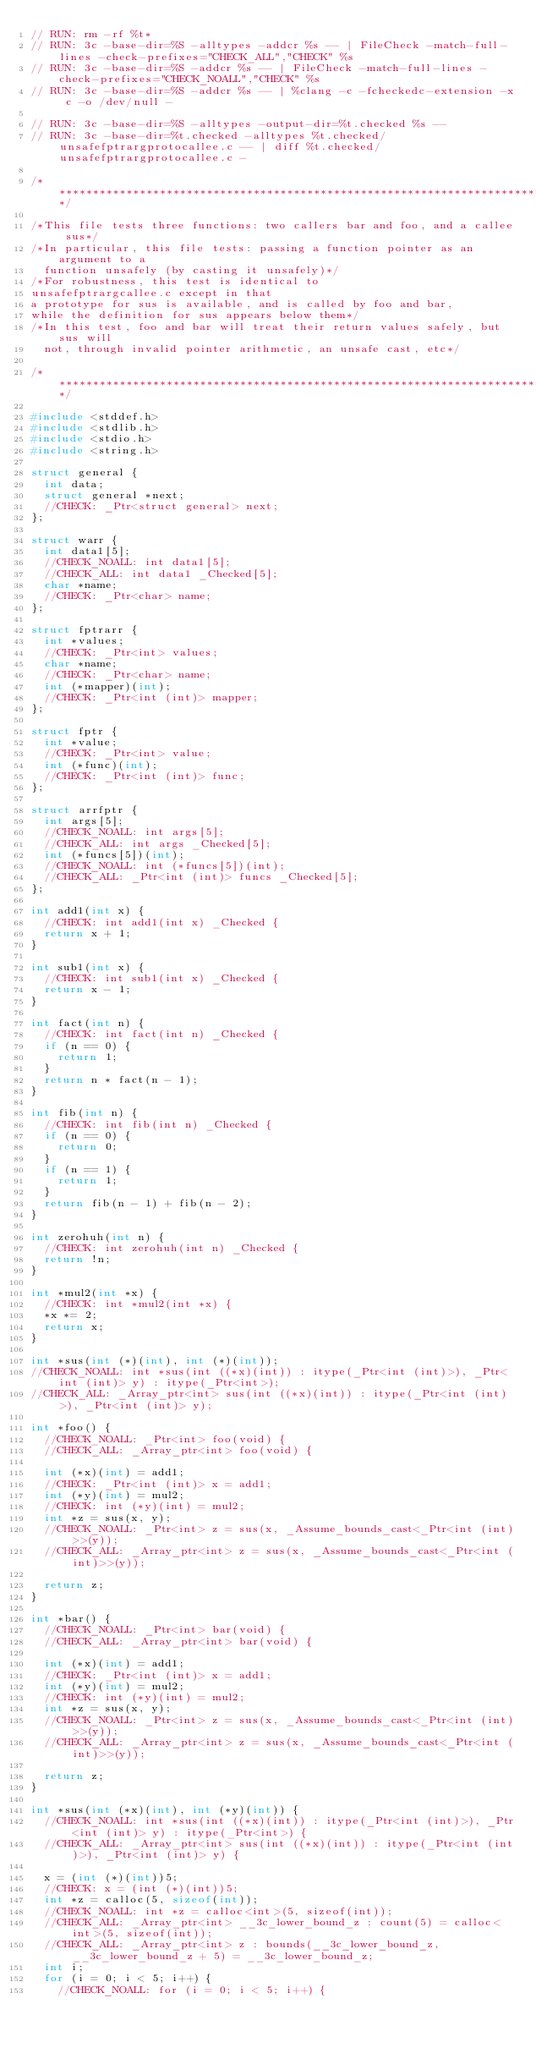<code> <loc_0><loc_0><loc_500><loc_500><_C_>// RUN: rm -rf %t*
// RUN: 3c -base-dir=%S -alltypes -addcr %s -- | FileCheck -match-full-lines -check-prefixes="CHECK_ALL","CHECK" %s
// RUN: 3c -base-dir=%S -addcr %s -- | FileCheck -match-full-lines -check-prefixes="CHECK_NOALL","CHECK" %s
// RUN: 3c -base-dir=%S -addcr %s -- | %clang -c -fcheckedc-extension -x c -o /dev/null -

// RUN: 3c -base-dir=%S -alltypes -output-dir=%t.checked %s --
// RUN: 3c -base-dir=%t.checked -alltypes %t.checked/unsafefptrargprotocallee.c -- | diff %t.checked/unsafefptrargprotocallee.c -

/******************************************************************************/

/*This file tests three functions: two callers bar and foo, and a callee sus*/
/*In particular, this file tests: passing a function pointer as an argument to a
  function unsafely (by casting it unsafely)*/
/*For robustness, this test is identical to
unsafefptrargcallee.c except in that
a prototype for sus is available, and is called by foo and bar,
while the definition for sus appears below them*/
/*In this test, foo and bar will treat their return values safely, but sus will
  not, through invalid pointer arithmetic, an unsafe cast, etc*/

/******************************************************************************/

#include <stddef.h>
#include <stdlib.h>
#include <stdio.h>
#include <string.h>

struct general {
  int data;
  struct general *next;
  //CHECK: _Ptr<struct general> next;
};

struct warr {
  int data1[5];
  //CHECK_NOALL: int data1[5];
  //CHECK_ALL: int data1 _Checked[5];
  char *name;
  //CHECK: _Ptr<char> name;
};

struct fptrarr {
  int *values;
  //CHECK: _Ptr<int> values;
  char *name;
  //CHECK: _Ptr<char> name;
  int (*mapper)(int);
  //CHECK: _Ptr<int (int)> mapper;
};

struct fptr {
  int *value;
  //CHECK: _Ptr<int> value;
  int (*func)(int);
  //CHECK: _Ptr<int (int)> func;
};

struct arrfptr {
  int args[5];
  //CHECK_NOALL: int args[5];
  //CHECK_ALL: int args _Checked[5];
  int (*funcs[5])(int);
  //CHECK_NOALL: int (*funcs[5])(int);
  //CHECK_ALL: _Ptr<int (int)> funcs _Checked[5];
};

int add1(int x) {
  //CHECK: int add1(int x) _Checked {
  return x + 1;
}

int sub1(int x) {
  //CHECK: int sub1(int x) _Checked {
  return x - 1;
}

int fact(int n) {
  //CHECK: int fact(int n) _Checked {
  if (n == 0) {
    return 1;
  }
  return n * fact(n - 1);
}

int fib(int n) {
  //CHECK: int fib(int n) _Checked {
  if (n == 0) {
    return 0;
  }
  if (n == 1) {
    return 1;
  }
  return fib(n - 1) + fib(n - 2);
}

int zerohuh(int n) {
  //CHECK: int zerohuh(int n) _Checked {
  return !n;
}

int *mul2(int *x) {
  //CHECK: int *mul2(int *x) {
  *x *= 2;
  return x;
}

int *sus(int (*)(int), int (*)(int));
//CHECK_NOALL: int *sus(int ((*x)(int)) : itype(_Ptr<int (int)>), _Ptr<int (int)> y) : itype(_Ptr<int>);
//CHECK_ALL: _Array_ptr<int> sus(int ((*x)(int)) : itype(_Ptr<int (int)>), _Ptr<int (int)> y);

int *foo() {
  //CHECK_NOALL: _Ptr<int> foo(void) {
  //CHECK_ALL: _Array_ptr<int> foo(void) {

  int (*x)(int) = add1;
  //CHECK: _Ptr<int (int)> x = add1;
  int (*y)(int) = mul2;
  //CHECK: int (*y)(int) = mul2;
  int *z = sus(x, y);
  //CHECK_NOALL: _Ptr<int> z = sus(x, _Assume_bounds_cast<_Ptr<int (int)>>(y));
  //CHECK_ALL: _Array_ptr<int> z = sus(x, _Assume_bounds_cast<_Ptr<int (int)>>(y));

  return z;
}

int *bar() {
  //CHECK_NOALL: _Ptr<int> bar(void) {
  //CHECK_ALL: _Array_ptr<int> bar(void) {

  int (*x)(int) = add1;
  //CHECK: _Ptr<int (int)> x = add1;
  int (*y)(int) = mul2;
  //CHECK: int (*y)(int) = mul2;
  int *z = sus(x, y);
  //CHECK_NOALL: _Ptr<int> z = sus(x, _Assume_bounds_cast<_Ptr<int (int)>>(y));
  //CHECK_ALL: _Array_ptr<int> z = sus(x, _Assume_bounds_cast<_Ptr<int (int)>>(y));

  return z;
}

int *sus(int (*x)(int), int (*y)(int)) {
  //CHECK_NOALL: int *sus(int ((*x)(int)) : itype(_Ptr<int (int)>), _Ptr<int (int)> y) : itype(_Ptr<int>) {
  //CHECK_ALL: _Array_ptr<int> sus(int ((*x)(int)) : itype(_Ptr<int (int)>), _Ptr<int (int)> y) {

  x = (int (*)(int))5;
  //CHECK: x = (int (*)(int))5;
  int *z = calloc(5, sizeof(int));
  //CHECK_NOALL: int *z = calloc<int>(5, sizeof(int));
  //CHECK_ALL: _Array_ptr<int> __3c_lower_bound_z : count(5) = calloc<int>(5, sizeof(int));
  //CHECK_ALL: _Array_ptr<int> z : bounds(__3c_lower_bound_z, __3c_lower_bound_z + 5) = __3c_lower_bound_z;
  int i;
  for (i = 0; i < 5; i++) {
    //CHECK_NOALL: for (i = 0; i < 5; i++) {</code> 